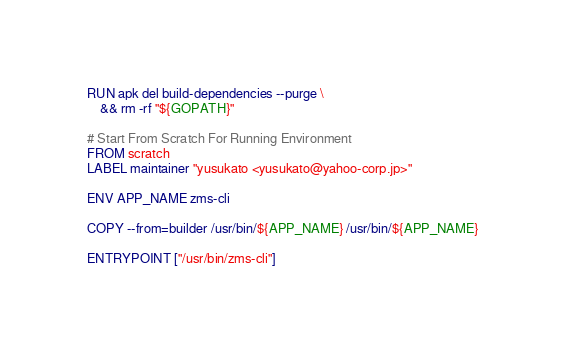Convert code to text. <code><loc_0><loc_0><loc_500><loc_500><_Dockerfile_>RUN apk del build-dependencies --purge \
    && rm -rf "${GOPATH}"

# Start From Scratch For Running Environment
FROM scratch
LABEL maintainer "yusukato <yusukato@yahoo-corp.jp>"

ENV APP_NAME zms-cli

COPY --from=builder /usr/bin/${APP_NAME} /usr/bin/${APP_NAME}

ENTRYPOINT ["/usr/bin/zms-cli"]
</code> 